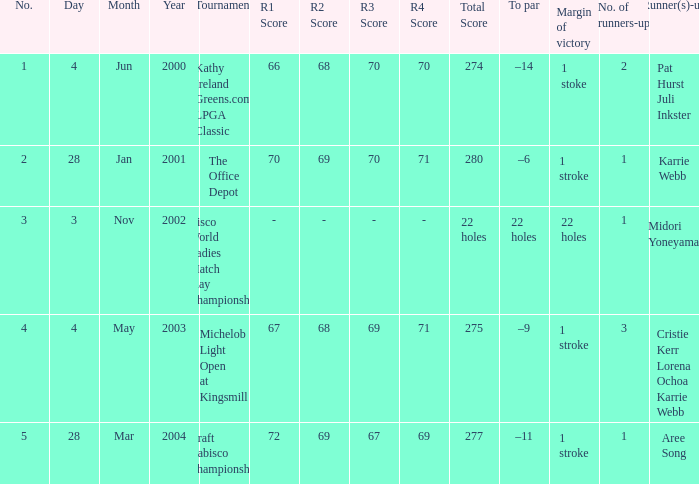What is the to par dated may 4, 2003? –9. 